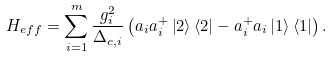Convert formula to latex. <formula><loc_0><loc_0><loc_500><loc_500>H _ { e f f } = \sum _ { i = 1 } ^ { m } \frac { g _ { i } ^ { 2 } } { \Delta _ { c , i } } \left ( a _ { i } a _ { i } ^ { + } \left | 2 \right \rangle \left \langle 2 \right | - a _ { i } ^ { + } a _ { i } \left | 1 \right \rangle \left \langle 1 \right | \right ) .</formula> 